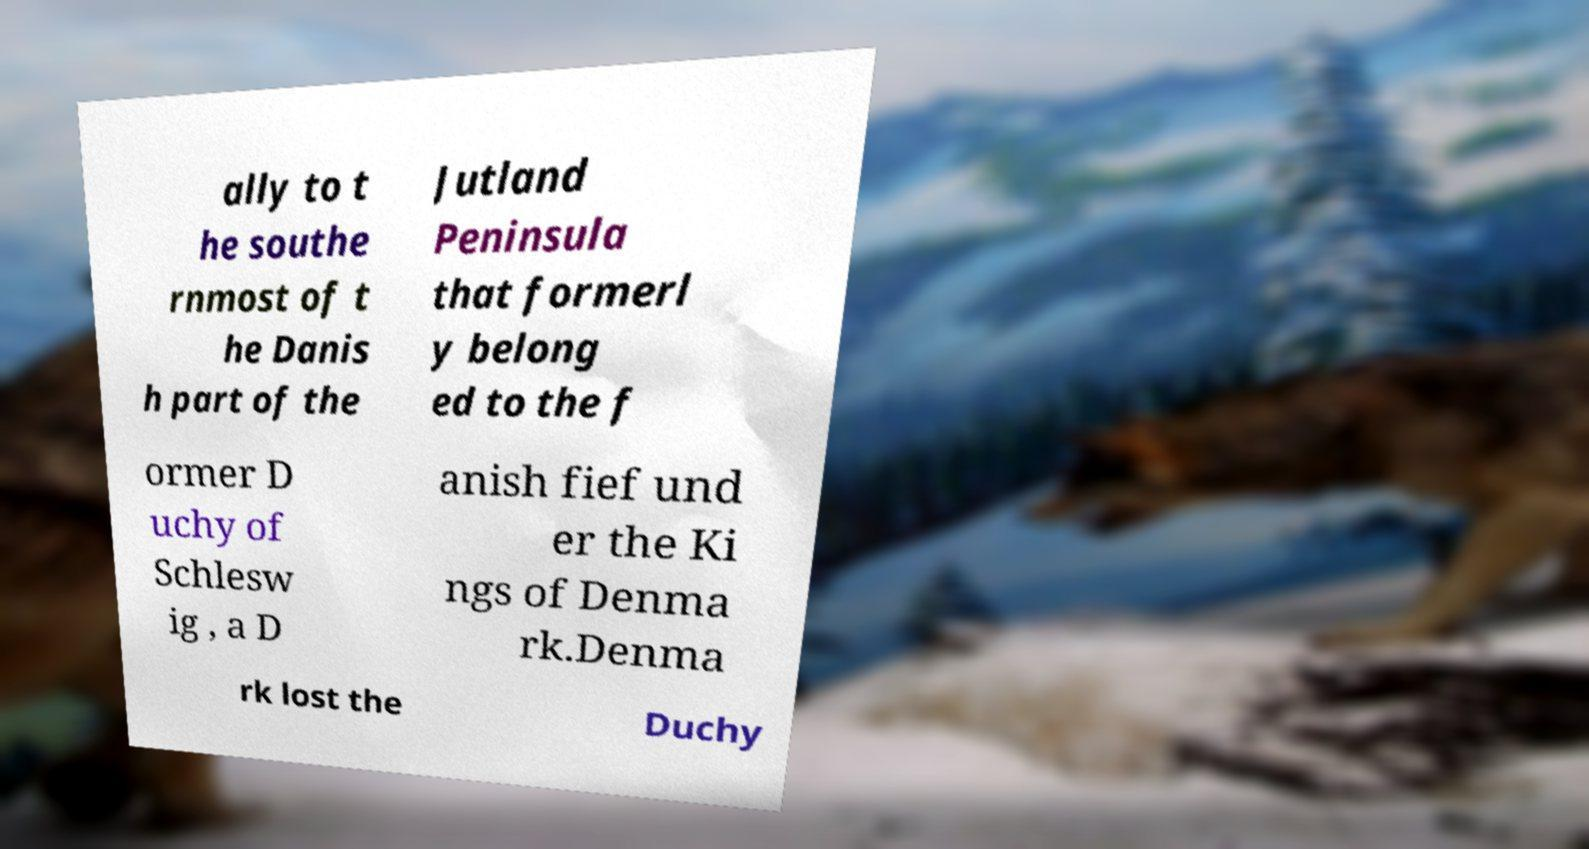Can you accurately transcribe the text from the provided image for me? ally to t he southe rnmost of t he Danis h part of the Jutland Peninsula that formerl y belong ed to the f ormer D uchy of Schlesw ig , a D anish fief und er the Ki ngs of Denma rk.Denma rk lost the Duchy 